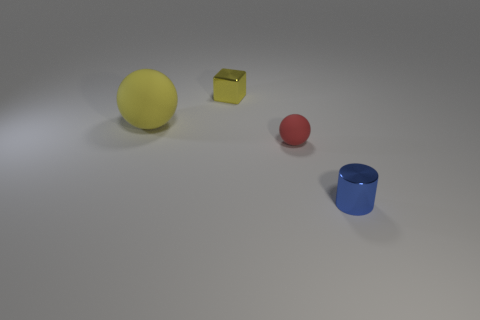There is a red ball that is in front of the rubber thing that is behind the red ball; how big is it?
Make the answer very short. Small. What number of objects are either large green rubber cylinders or small shiny cubes?
Offer a very short reply. 1. Is there a large object that has the same color as the big rubber ball?
Provide a short and direct response. No. Is the number of big red matte cubes less than the number of big yellow balls?
Make the answer very short. Yes. What number of objects are either yellow blocks or things behind the tiny blue thing?
Ensure brevity in your answer.  3. Are there any gray spheres that have the same material as the cube?
Offer a terse response. No. There is a yellow block that is the same size as the red sphere; what is it made of?
Offer a terse response. Metal. The object on the left side of the tiny metal object on the left side of the tiny metallic cylinder is made of what material?
Keep it short and to the point. Rubber. There is a matte thing that is on the left side of the cube; does it have the same shape as the tiny blue object?
Offer a very short reply. No. There is a object that is the same material as the big yellow sphere; what color is it?
Your answer should be compact. Red. 